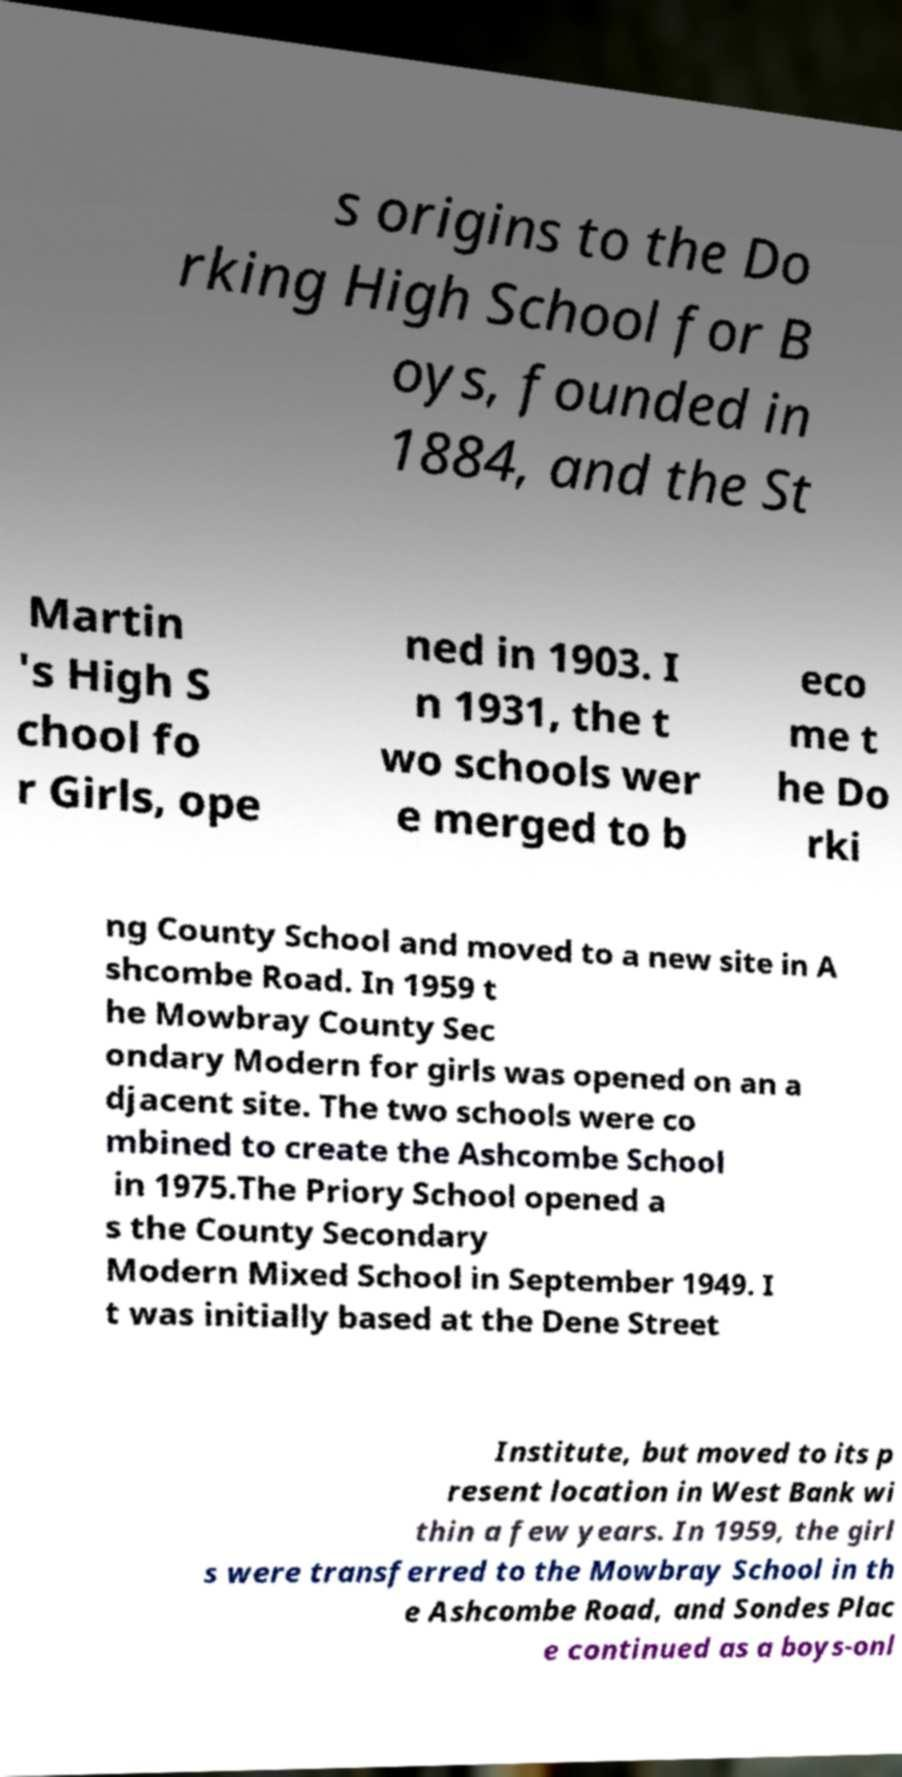Could you assist in decoding the text presented in this image and type it out clearly? s origins to the Do rking High School for B oys, founded in 1884, and the St Martin 's High S chool fo r Girls, ope ned in 1903. I n 1931, the t wo schools wer e merged to b eco me t he Do rki ng County School and moved to a new site in A shcombe Road. In 1959 t he Mowbray County Sec ondary Modern for girls was opened on an a djacent site. The two schools were co mbined to create the Ashcombe School in 1975.The Priory School opened a s the County Secondary Modern Mixed School in September 1949. I t was initially based at the Dene Street Institute, but moved to its p resent location in West Bank wi thin a few years. In 1959, the girl s were transferred to the Mowbray School in th e Ashcombe Road, and Sondes Plac e continued as a boys-onl 